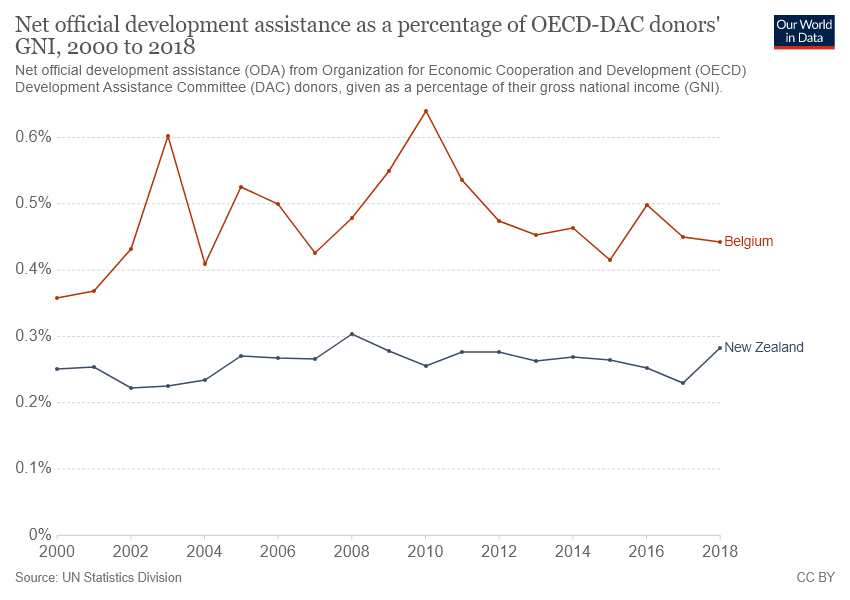Indicate a few pertinent items in this graphic. The red graph's first value is not greater than its last value when considered from left to right. The value of net official development assistance as a percentage of OECD-DAC donors peaked in Belgium in 2010. 